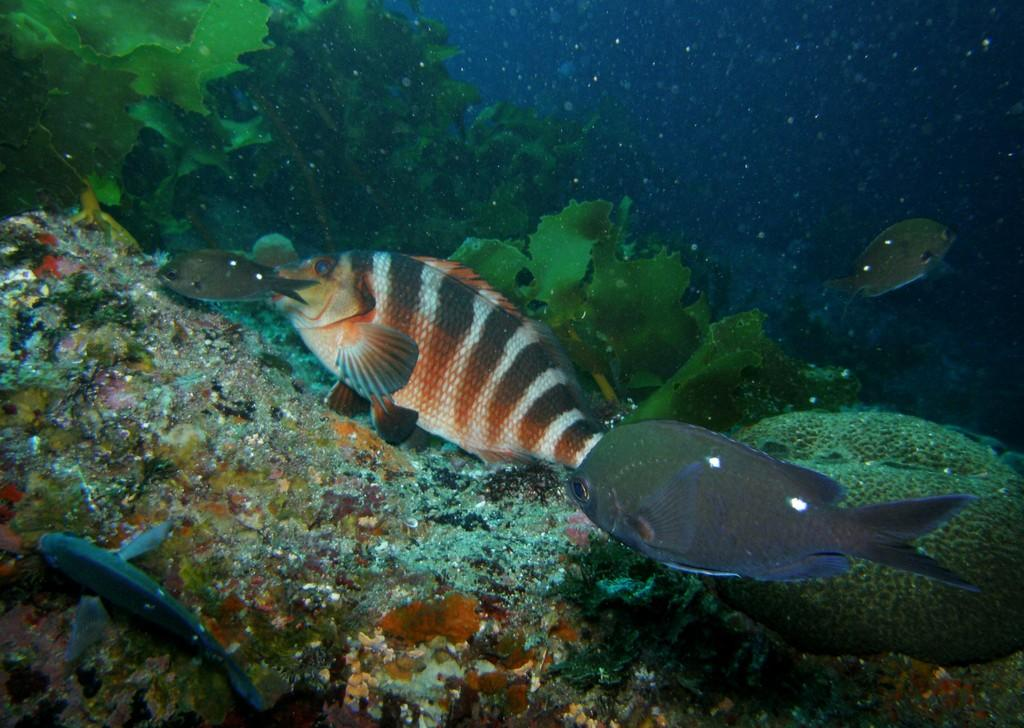What type of animals can be seen in the image? There are fishes in the water. What else can be seen in the water besides the fishes? There are plants in the water. What type of door can be seen in the image? There is no door present in the image; it features fishes and plants in the water. How are the fishes maintaining their balance in the image? The fishes do not need to maintain their balance in the image, as they are swimming freely in the water. 